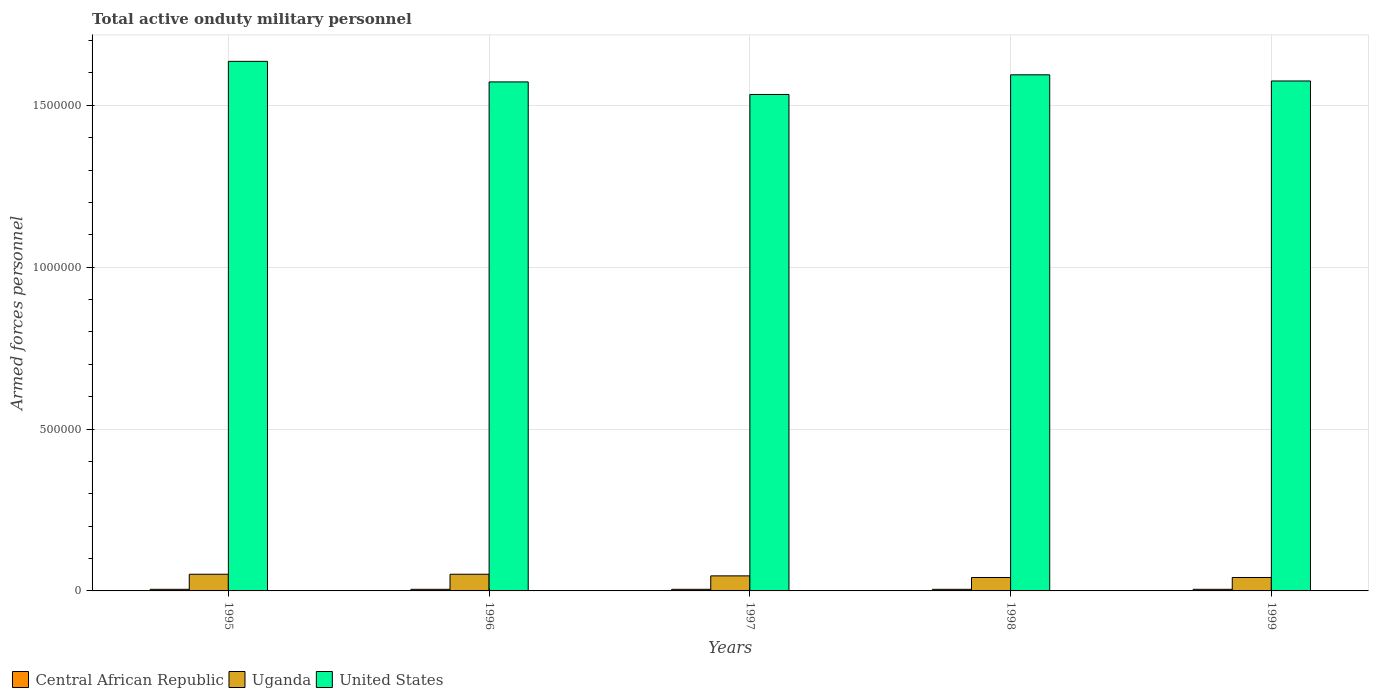Are the number of bars on each tick of the X-axis equal?
Make the answer very short. Yes. How many bars are there on the 5th tick from the left?
Offer a terse response. 3. What is the label of the 4th group of bars from the left?
Offer a very short reply. 1998. In how many cases, is the number of bars for a given year not equal to the number of legend labels?
Your response must be concise. 0. Across all years, what is the maximum number of armed forces personnel in Uganda?
Your response must be concise. 5.15e+04. Across all years, what is the minimum number of armed forces personnel in Uganda?
Provide a short and direct response. 4.15e+04. In which year was the number of armed forces personnel in United States maximum?
Give a very brief answer. 1995. What is the total number of armed forces personnel in Uganda in the graph?
Keep it short and to the point. 2.32e+05. What is the difference between the number of armed forces personnel in Central African Republic in 1996 and the number of armed forces personnel in Uganda in 1999?
Your response must be concise. -3.65e+04. What is the average number of armed forces personnel in Uganda per year?
Keep it short and to the point. 4.65e+04. In the year 1997, what is the difference between the number of armed forces personnel in Uganda and number of armed forces personnel in United States?
Provide a short and direct response. -1.49e+06. What is the ratio of the number of armed forces personnel in United States in 1996 to that in 1997?
Your answer should be compact. 1.03. Is the number of armed forces personnel in United States in 1997 less than that in 1998?
Offer a very short reply. Yes. What is the difference between the highest and the second highest number of armed forces personnel in United States?
Provide a succinct answer. 4.16e+04. What is the difference between the highest and the lowest number of armed forces personnel in United States?
Your answer should be very brief. 1.02e+05. In how many years, is the number of armed forces personnel in United States greater than the average number of armed forces personnel in United States taken over all years?
Your answer should be compact. 2. What does the 3rd bar from the right in 1995 represents?
Your answer should be compact. Central African Republic. Is it the case that in every year, the sum of the number of armed forces personnel in Central African Republic and number of armed forces personnel in Uganda is greater than the number of armed forces personnel in United States?
Provide a short and direct response. No. Are all the bars in the graph horizontal?
Offer a very short reply. No. How many years are there in the graph?
Offer a terse response. 5. What is the difference between two consecutive major ticks on the Y-axis?
Your response must be concise. 5.00e+05. Are the values on the major ticks of Y-axis written in scientific E-notation?
Provide a short and direct response. No. Does the graph contain grids?
Provide a short and direct response. Yes. Where does the legend appear in the graph?
Your answer should be very brief. Bottom left. What is the title of the graph?
Ensure brevity in your answer.  Total active onduty military personnel. What is the label or title of the X-axis?
Provide a short and direct response. Years. What is the label or title of the Y-axis?
Ensure brevity in your answer.  Armed forces personnel. What is the Armed forces personnel in Uganda in 1995?
Give a very brief answer. 5.15e+04. What is the Armed forces personnel of United States in 1995?
Offer a very short reply. 1.64e+06. What is the Armed forces personnel of Central African Republic in 1996?
Your answer should be very brief. 5000. What is the Armed forces personnel of Uganda in 1996?
Your answer should be compact. 5.15e+04. What is the Armed forces personnel of United States in 1996?
Offer a very short reply. 1.57e+06. What is the Armed forces personnel in Uganda in 1997?
Provide a succinct answer. 4.65e+04. What is the Armed forces personnel of United States in 1997?
Give a very brief answer. 1.53e+06. What is the Armed forces personnel in Central African Republic in 1998?
Ensure brevity in your answer.  4950. What is the Armed forces personnel of Uganda in 1998?
Make the answer very short. 4.15e+04. What is the Armed forces personnel of United States in 1998?
Your answer should be compact. 1.59e+06. What is the Armed forces personnel of Uganda in 1999?
Offer a terse response. 4.15e+04. What is the Armed forces personnel of United States in 1999?
Keep it short and to the point. 1.58e+06. Across all years, what is the maximum Armed forces personnel in Uganda?
Give a very brief answer. 5.15e+04. Across all years, what is the maximum Armed forces personnel of United States?
Offer a terse response. 1.64e+06. Across all years, what is the minimum Armed forces personnel in Central African Republic?
Your answer should be compact. 4950. Across all years, what is the minimum Armed forces personnel in Uganda?
Ensure brevity in your answer.  4.15e+04. Across all years, what is the minimum Armed forces personnel of United States?
Your answer should be compact. 1.53e+06. What is the total Armed forces personnel in Central African Republic in the graph?
Your response must be concise. 2.50e+04. What is the total Armed forces personnel in Uganda in the graph?
Offer a terse response. 2.32e+05. What is the total Armed forces personnel of United States in the graph?
Offer a very short reply. 7.91e+06. What is the difference between the Armed forces personnel in Central African Republic in 1995 and that in 1996?
Offer a very short reply. 0. What is the difference between the Armed forces personnel in United States in 1995 and that in 1996?
Provide a short and direct response. 6.35e+04. What is the difference between the Armed forces personnel of Central African Republic in 1995 and that in 1997?
Make the answer very short. 0. What is the difference between the Armed forces personnel in United States in 1995 and that in 1997?
Your answer should be very brief. 1.02e+05. What is the difference between the Armed forces personnel in United States in 1995 and that in 1998?
Offer a terse response. 4.16e+04. What is the difference between the Armed forces personnel in Central African Republic in 1995 and that in 1999?
Make the answer very short. 0. What is the difference between the Armed forces personnel of United States in 1995 and that in 1999?
Make the answer very short. 6.06e+04. What is the difference between the Armed forces personnel of United States in 1996 and that in 1997?
Offer a very short reply. 3.88e+04. What is the difference between the Armed forces personnel in Uganda in 1996 and that in 1998?
Your answer should be very brief. 10000. What is the difference between the Armed forces personnel in United States in 1996 and that in 1998?
Provide a succinct answer. -2.19e+04. What is the difference between the Armed forces personnel of Central African Republic in 1996 and that in 1999?
Offer a terse response. 0. What is the difference between the Armed forces personnel of United States in 1996 and that in 1999?
Your answer should be very brief. -2900. What is the difference between the Armed forces personnel in United States in 1997 and that in 1998?
Offer a terse response. -6.07e+04. What is the difference between the Armed forces personnel of United States in 1997 and that in 1999?
Provide a succinct answer. -4.17e+04. What is the difference between the Armed forces personnel of Central African Republic in 1998 and that in 1999?
Give a very brief answer. -50. What is the difference between the Armed forces personnel of Uganda in 1998 and that in 1999?
Make the answer very short. 0. What is the difference between the Armed forces personnel of United States in 1998 and that in 1999?
Provide a short and direct response. 1.90e+04. What is the difference between the Armed forces personnel in Central African Republic in 1995 and the Armed forces personnel in Uganda in 1996?
Offer a very short reply. -4.65e+04. What is the difference between the Armed forces personnel of Central African Republic in 1995 and the Armed forces personnel of United States in 1996?
Your response must be concise. -1.57e+06. What is the difference between the Armed forces personnel in Uganda in 1995 and the Armed forces personnel in United States in 1996?
Make the answer very short. -1.52e+06. What is the difference between the Armed forces personnel of Central African Republic in 1995 and the Armed forces personnel of Uganda in 1997?
Give a very brief answer. -4.15e+04. What is the difference between the Armed forces personnel in Central African Republic in 1995 and the Armed forces personnel in United States in 1997?
Keep it short and to the point. -1.53e+06. What is the difference between the Armed forces personnel of Uganda in 1995 and the Armed forces personnel of United States in 1997?
Provide a succinct answer. -1.48e+06. What is the difference between the Armed forces personnel in Central African Republic in 1995 and the Armed forces personnel in Uganda in 1998?
Give a very brief answer. -3.65e+04. What is the difference between the Armed forces personnel of Central African Republic in 1995 and the Armed forces personnel of United States in 1998?
Offer a terse response. -1.59e+06. What is the difference between the Armed forces personnel in Uganda in 1995 and the Armed forces personnel in United States in 1998?
Give a very brief answer. -1.54e+06. What is the difference between the Armed forces personnel in Central African Republic in 1995 and the Armed forces personnel in Uganda in 1999?
Keep it short and to the point. -3.65e+04. What is the difference between the Armed forces personnel of Central African Republic in 1995 and the Armed forces personnel of United States in 1999?
Make the answer very short. -1.57e+06. What is the difference between the Armed forces personnel of Uganda in 1995 and the Armed forces personnel of United States in 1999?
Your response must be concise. -1.52e+06. What is the difference between the Armed forces personnel of Central African Republic in 1996 and the Armed forces personnel of Uganda in 1997?
Your answer should be compact. -4.15e+04. What is the difference between the Armed forces personnel in Central African Republic in 1996 and the Armed forces personnel in United States in 1997?
Provide a short and direct response. -1.53e+06. What is the difference between the Armed forces personnel in Uganda in 1996 and the Armed forces personnel in United States in 1997?
Ensure brevity in your answer.  -1.48e+06. What is the difference between the Armed forces personnel in Central African Republic in 1996 and the Armed forces personnel in Uganda in 1998?
Make the answer very short. -3.65e+04. What is the difference between the Armed forces personnel in Central African Republic in 1996 and the Armed forces personnel in United States in 1998?
Keep it short and to the point. -1.59e+06. What is the difference between the Armed forces personnel of Uganda in 1996 and the Armed forces personnel of United States in 1998?
Your response must be concise. -1.54e+06. What is the difference between the Armed forces personnel of Central African Republic in 1996 and the Armed forces personnel of Uganda in 1999?
Your answer should be very brief. -3.65e+04. What is the difference between the Armed forces personnel in Central African Republic in 1996 and the Armed forces personnel in United States in 1999?
Offer a very short reply. -1.57e+06. What is the difference between the Armed forces personnel of Uganda in 1996 and the Armed forces personnel of United States in 1999?
Give a very brief answer. -1.52e+06. What is the difference between the Armed forces personnel of Central African Republic in 1997 and the Armed forces personnel of Uganda in 1998?
Your answer should be very brief. -3.65e+04. What is the difference between the Armed forces personnel of Central African Republic in 1997 and the Armed forces personnel of United States in 1998?
Your answer should be compact. -1.59e+06. What is the difference between the Armed forces personnel of Uganda in 1997 and the Armed forces personnel of United States in 1998?
Give a very brief answer. -1.55e+06. What is the difference between the Armed forces personnel of Central African Republic in 1997 and the Armed forces personnel of Uganda in 1999?
Your answer should be very brief. -3.65e+04. What is the difference between the Armed forces personnel of Central African Republic in 1997 and the Armed forces personnel of United States in 1999?
Offer a terse response. -1.57e+06. What is the difference between the Armed forces personnel in Uganda in 1997 and the Armed forces personnel in United States in 1999?
Keep it short and to the point. -1.53e+06. What is the difference between the Armed forces personnel in Central African Republic in 1998 and the Armed forces personnel in Uganda in 1999?
Provide a succinct answer. -3.66e+04. What is the difference between the Armed forces personnel of Central African Republic in 1998 and the Armed forces personnel of United States in 1999?
Provide a succinct answer. -1.57e+06. What is the difference between the Armed forces personnel in Uganda in 1998 and the Armed forces personnel in United States in 1999?
Provide a short and direct response. -1.53e+06. What is the average Armed forces personnel in Central African Republic per year?
Provide a short and direct response. 4990. What is the average Armed forces personnel of Uganda per year?
Offer a very short reply. 4.65e+04. What is the average Armed forces personnel in United States per year?
Keep it short and to the point. 1.58e+06. In the year 1995, what is the difference between the Armed forces personnel in Central African Republic and Armed forces personnel in Uganda?
Offer a terse response. -4.65e+04. In the year 1995, what is the difference between the Armed forces personnel in Central African Republic and Armed forces personnel in United States?
Ensure brevity in your answer.  -1.63e+06. In the year 1995, what is the difference between the Armed forces personnel in Uganda and Armed forces personnel in United States?
Ensure brevity in your answer.  -1.58e+06. In the year 1996, what is the difference between the Armed forces personnel in Central African Republic and Armed forces personnel in Uganda?
Your response must be concise. -4.65e+04. In the year 1996, what is the difference between the Armed forces personnel of Central African Republic and Armed forces personnel of United States?
Your answer should be very brief. -1.57e+06. In the year 1996, what is the difference between the Armed forces personnel of Uganda and Armed forces personnel of United States?
Ensure brevity in your answer.  -1.52e+06. In the year 1997, what is the difference between the Armed forces personnel in Central African Republic and Armed forces personnel in Uganda?
Give a very brief answer. -4.15e+04. In the year 1997, what is the difference between the Armed forces personnel of Central African Republic and Armed forces personnel of United States?
Offer a very short reply. -1.53e+06. In the year 1997, what is the difference between the Armed forces personnel of Uganda and Armed forces personnel of United States?
Your answer should be compact. -1.49e+06. In the year 1998, what is the difference between the Armed forces personnel in Central African Republic and Armed forces personnel in Uganda?
Give a very brief answer. -3.66e+04. In the year 1998, what is the difference between the Armed forces personnel in Central African Republic and Armed forces personnel in United States?
Your answer should be compact. -1.59e+06. In the year 1998, what is the difference between the Armed forces personnel of Uganda and Armed forces personnel of United States?
Keep it short and to the point. -1.55e+06. In the year 1999, what is the difference between the Armed forces personnel in Central African Republic and Armed forces personnel in Uganda?
Your response must be concise. -3.65e+04. In the year 1999, what is the difference between the Armed forces personnel in Central African Republic and Armed forces personnel in United States?
Your response must be concise. -1.57e+06. In the year 1999, what is the difference between the Armed forces personnel in Uganda and Armed forces personnel in United States?
Your answer should be very brief. -1.53e+06. What is the ratio of the Armed forces personnel in Central African Republic in 1995 to that in 1996?
Your answer should be compact. 1. What is the ratio of the Armed forces personnel of United States in 1995 to that in 1996?
Your answer should be very brief. 1.04. What is the ratio of the Armed forces personnel of Central African Republic in 1995 to that in 1997?
Provide a succinct answer. 1. What is the ratio of the Armed forces personnel of Uganda in 1995 to that in 1997?
Provide a succinct answer. 1.11. What is the ratio of the Armed forces personnel in United States in 1995 to that in 1997?
Provide a short and direct response. 1.07. What is the ratio of the Armed forces personnel in Central African Republic in 1995 to that in 1998?
Ensure brevity in your answer.  1.01. What is the ratio of the Armed forces personnel of Uganda in 1995 to that in 1998?
Make the answer very short. 1.24. What is the ratio of the Armed forces personnel of United States in 1995 to that in 1998?
Offer a terse response. 1.03. What is the ratio of the Armed forces personnel of Uganda in 1995 to that in 1999?
Your answer should be compact. 1.24. What is the ratio of the Armed forces personnel of United States in 1995 to that in 1999?
Provide a succinct answer. 1.04. What is the ratio of the Armed forces personnel in Central African Republic in 1996 to that in 1997?
Provide a succinct answer. 1. What is the ratio of the Armed forces personnel of Uganda in 1996 to that in 1997?
Your answer should be compact. 1.11. What is the ratio of the Armed forces personnel of United States in 1996 to that in 1997?
Your answer should be compact. 1.03. What is the ratio of the Armed forces personnel of Central African Republic in 1996 to that in 1998?
Your answer should be compact. 1.01. What is the ratio of the Armed forces personnel in Uganda in 1996 to that in 1998?
Offer a terse response. 1.24. What is the ratio of the Armed forces personnel in United States in 1996 to that in 1998?
Make the answer very short. 0.99. What is the ratio of the Armed forces personnel of Uganda in 1996 to that in 1999?
Provide a short and direct response. 1.24. What is the ratio of the Armed forces personnel of Central African Republic in 1997 to that in 1998?
Offer a very short reply. 1.01. What is the ratio of the Armed forces personnel in Uganda in 1997 to that in 1998?
Your answer should be very brief. 1.12. What is the ratio of the Armed forces personnel of United States in 1997 to that in 1998?
Offer a very short reply. 0.96. What is the ratio of the Armed forces personnel in Central African Republic in 1997 to that in 1999?
Give a very brief answer. 1. What is the ratio of the Armed forces personnel in Uganda in 1997 to that in 1999?
Provide a succinct answer. 1.12. What is the ratio of the Armed forces personnel in United States in 1997 to that in 1999?
Your response must be concise. 0.97. What is the ratio of the Armed forces personnel in Uganda in 1998 to that in 1999?
Make the answer very short. 1. What is the ratio of the Armed forces personnel of United States in 1998 to that in 1999?
Offer a terse response. 1.01. What is the difference between the highest and the second highest Armed forces personnel in United States?
Make the answer very short. 4.16e+04. What is the difference between the highest and the lowest Armed forces personnel of Central African Republic?
Give a very brief answer. 50. What is the difference between the highest and the lowest Armed forces personnel of Uganda?
Make the answer very short. 10000. What is the difference between the highest and the lowest Armed forces personnel in United States?
Your answer should be very brief. 1.02e+05. 